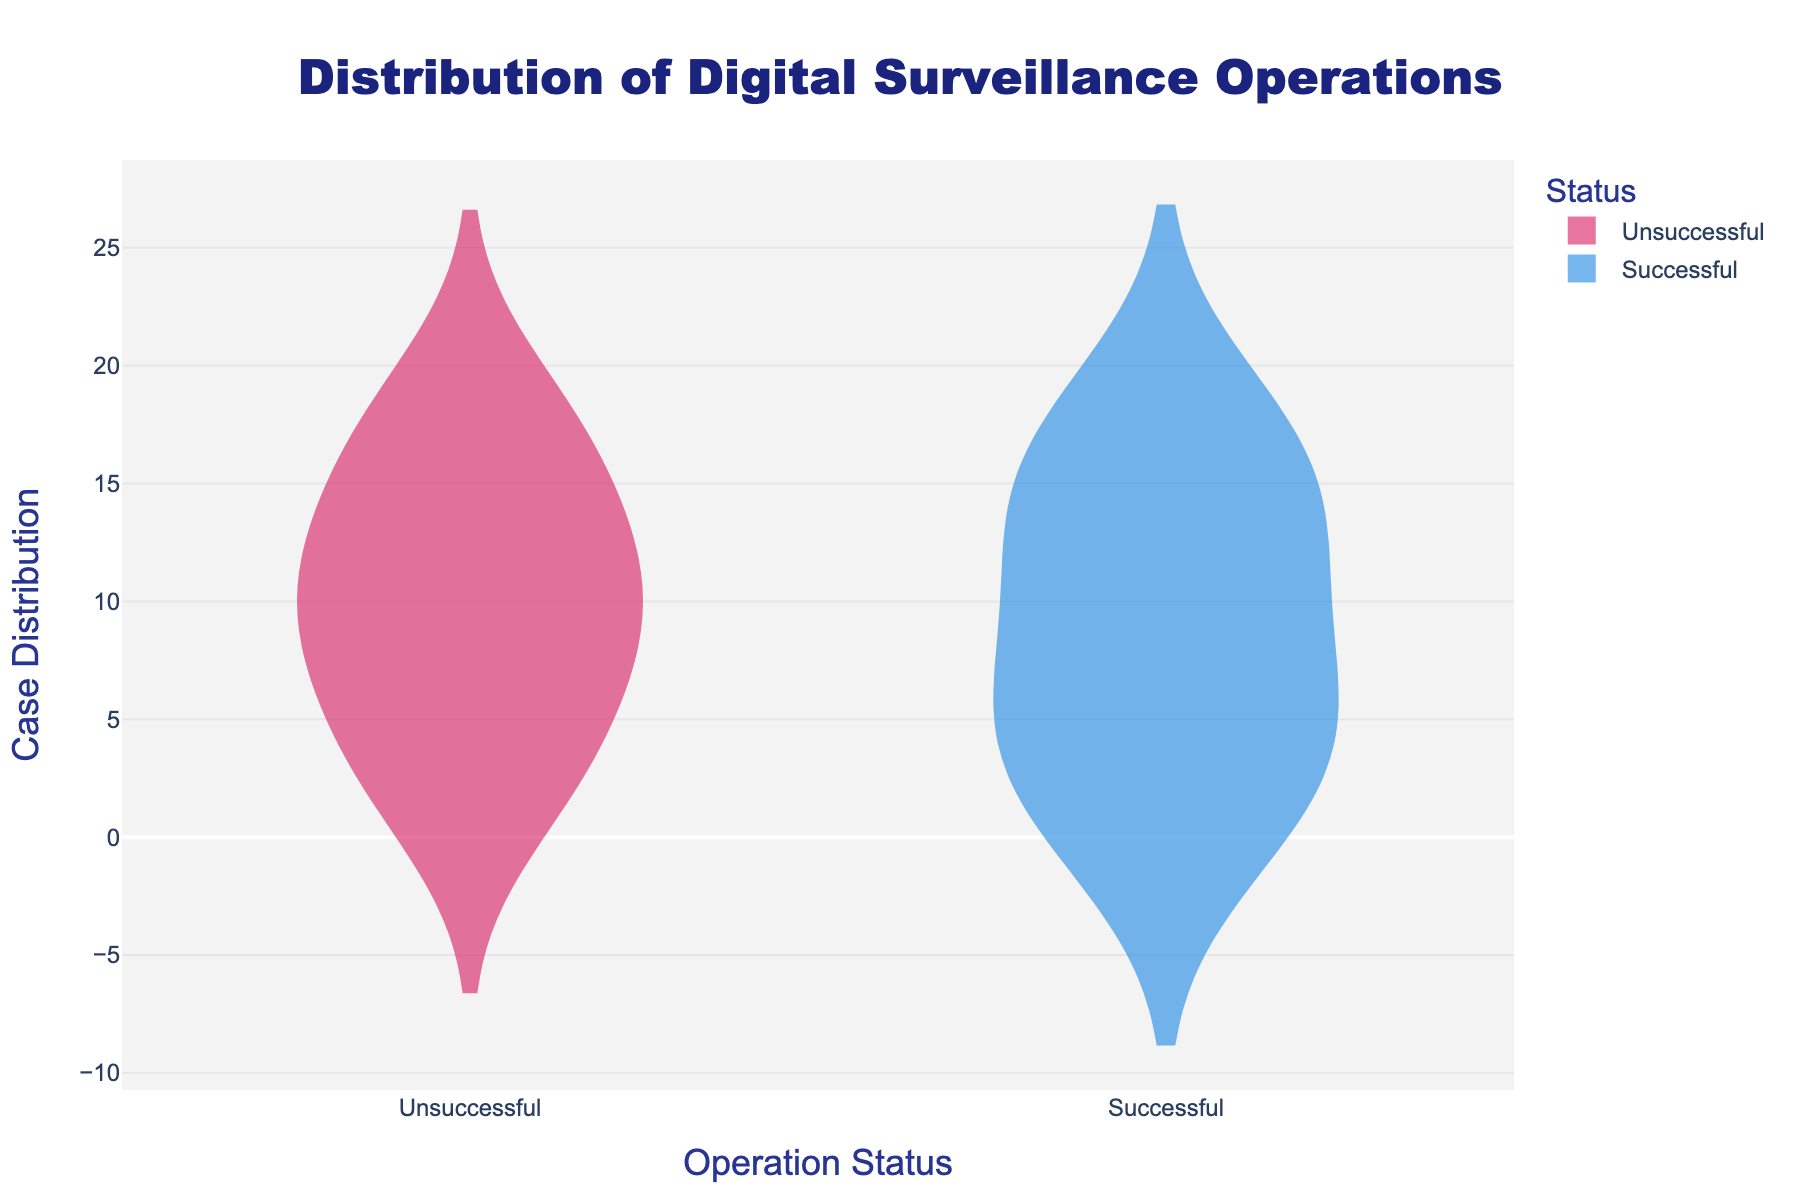What is the title of the plot? The title is prominently displayed at the top of the figure. It reads "Distribution of Digital Surveillance Operations."
Answer: Distribution of Digital Surveillance Operations How many cases were successful? The plot shows the distribution of cases along the x-axis. There are 9 points on the "Successful" side.
Answer: 9 Which operation status has more cases, 'Successful' or 'Unsuccessful'? The plot shows two categories: 'Successful' and 'Unsuccessful'. The 'Unsuccessful' category has more points than the 'Successful' category.
Answer: Unsuccessful What color represents unsuccessful cases? Unsuccessful cases are shown with a distinct color on the plot. The color is a shade of pink or red.
Answer: Pink or red How do the mean lines compare for successful and unsuccessful cases? Mean lines are visible on each violin plot, indicating the average distribution of cases. Both mean lines are displayed at approximately the middle of each distribution, but the exact comparison requires closer inspection.
Answer: Slightly skewed but roughly in the middle What is the difference in the counts between successful and unsuccessful cases? There are 11 unsuccessful cases and 9 successful cases. The difference is calculated as 11 - 9.
Answer: 2 Which status has a wider spread of cases? The spread of cases is illustrated by the width of the violin plots. The 'Unsuccessful' status shows a wider distribution than the 'Successful' status.
Answer: Unsuccessful What feature makes the average value clear on the plot? The plot includes mean lines (marked as a horizontal line within the violin shapes) to indicate where the average value lies.
Answer: Mean lines What is the y-axis label of the plot? The y-axis label is written along the y-axis and reads "Case Distribution."
Answer: Case Distribution What operation status do most cases fall under? By observing the number of points under each status on the x-axis, most cases fall under 'Unsuccessful'.
Answer: Unsuccessful 